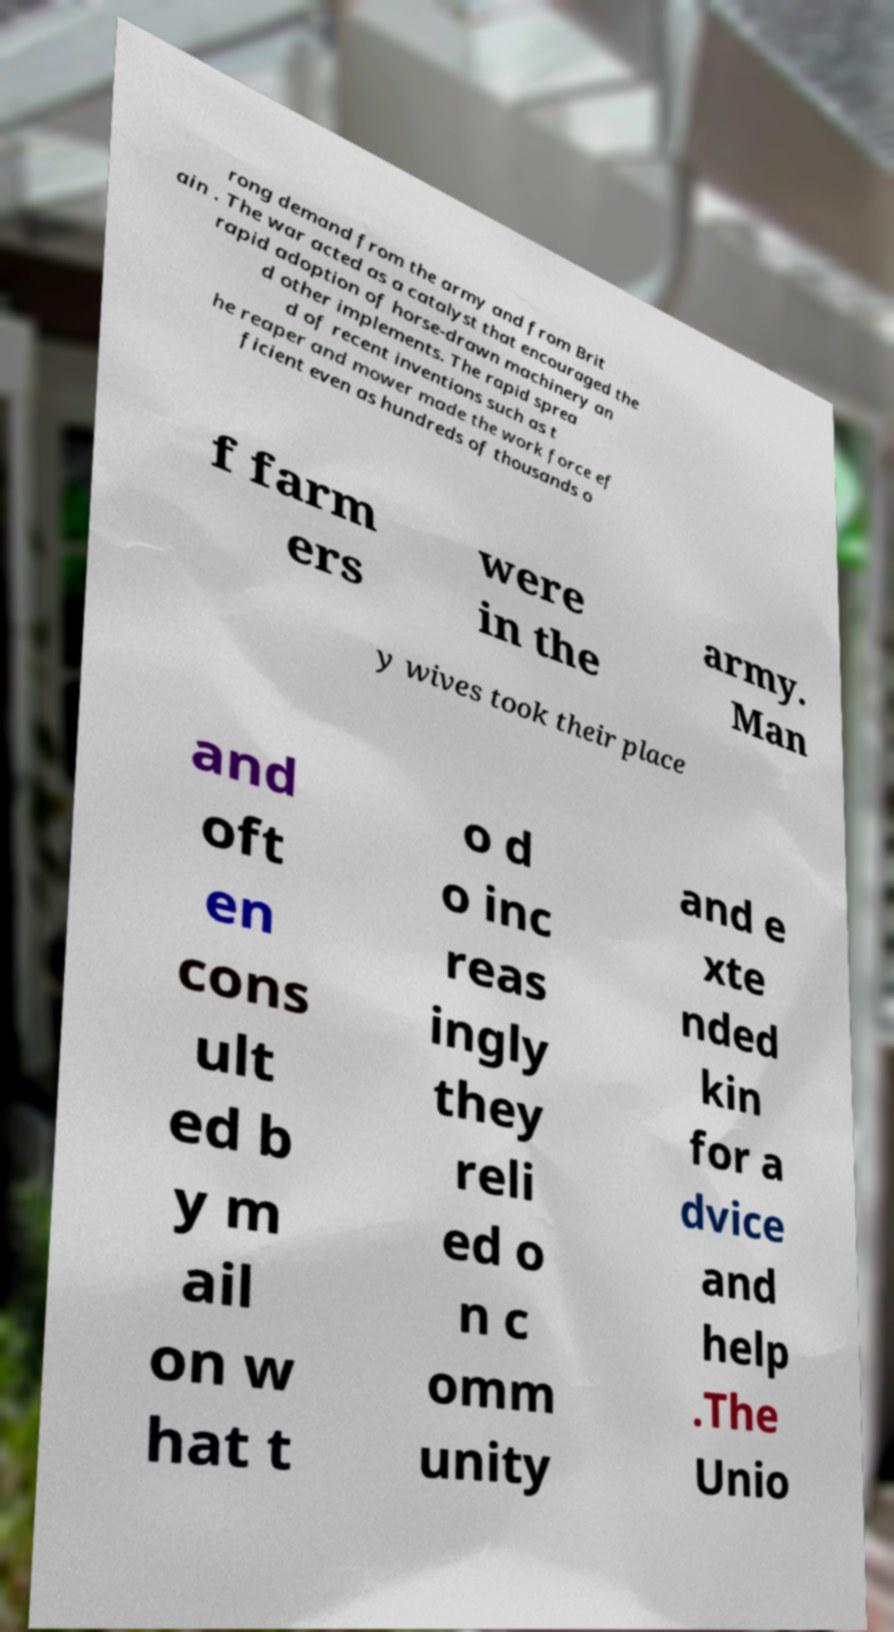I need the written content from this picture converted into text. Can you do that? rong demand from the army and from Brit ain . The war acted as a catalyst that encouraged the rapid adoption of horse-drawn machinery an d other implements. The rapid sprea d of recent inventions such as t he reaper and mower made the work force ef ficient even as hundreds of thousands o f farm ers were in the army. Man y wives took their place and oft en cons ult ed b y m ail on w hat t o d o inc reas ingly they reli ed o n c omm unity and e xte nded kin for a dvice and help .The Unio 